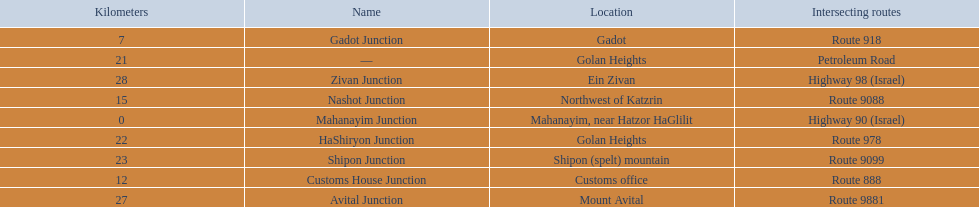How many kilometers away is shipon junction? 23. How many kilometers away is avital junction? 27. Which one is closer to nashot junction? Shipon Junction. 